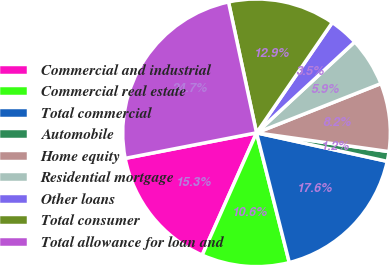Convert chart. <chart><loc_0><loc_0><loc_500><loc_500><pie_chart><fcel>Commercial and industrial<fcel>Commercial real estate<fcel>Total commercial<fcel>Automobile<fcel>Home equity<fcel>Residential mortgage<fcel>Other loans<fcel>Total consumer<fcel>Total allowance for loan and<nl><fcel>15.29%<fcel>10.59%<fcel>17.64%<fcel>1.18%<fcel>8.24%<fcel>5.89%<fcel>3.53%<fcel>12.94%<fcel>24.7%<nl></chart> 